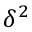Convert formula to latex. <formula><loc_0><loc_0><loc_500><loc_500>\delta ^ { 2 }</formula> 